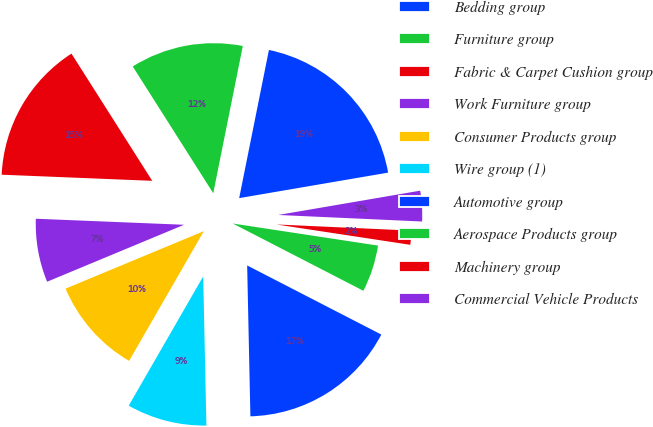<chart> <loc_0><loc_0><loc_500><loc_500><pie_chart><fcel>Bedding group<fcel>Furniture group<fcel>Fabric & Carpet Cushion group<fcel>Work Furniture group<fcel>Consumer Products group<fcel>Wire group (1)<fcel>Automotive group<fcel>Aerospace Products group<fcel>Machinery group<fcel>Commercial Vehicle Products<nl><fcel>19.15%<fcel>12.16%<fcel>15.35%<fcel>6.92%<fcel>10.41%<fcel>8.66%<fcel>17.09%<fcel>5.17%<fcel>1.68%<fcel>3.42%<nl></chart> 